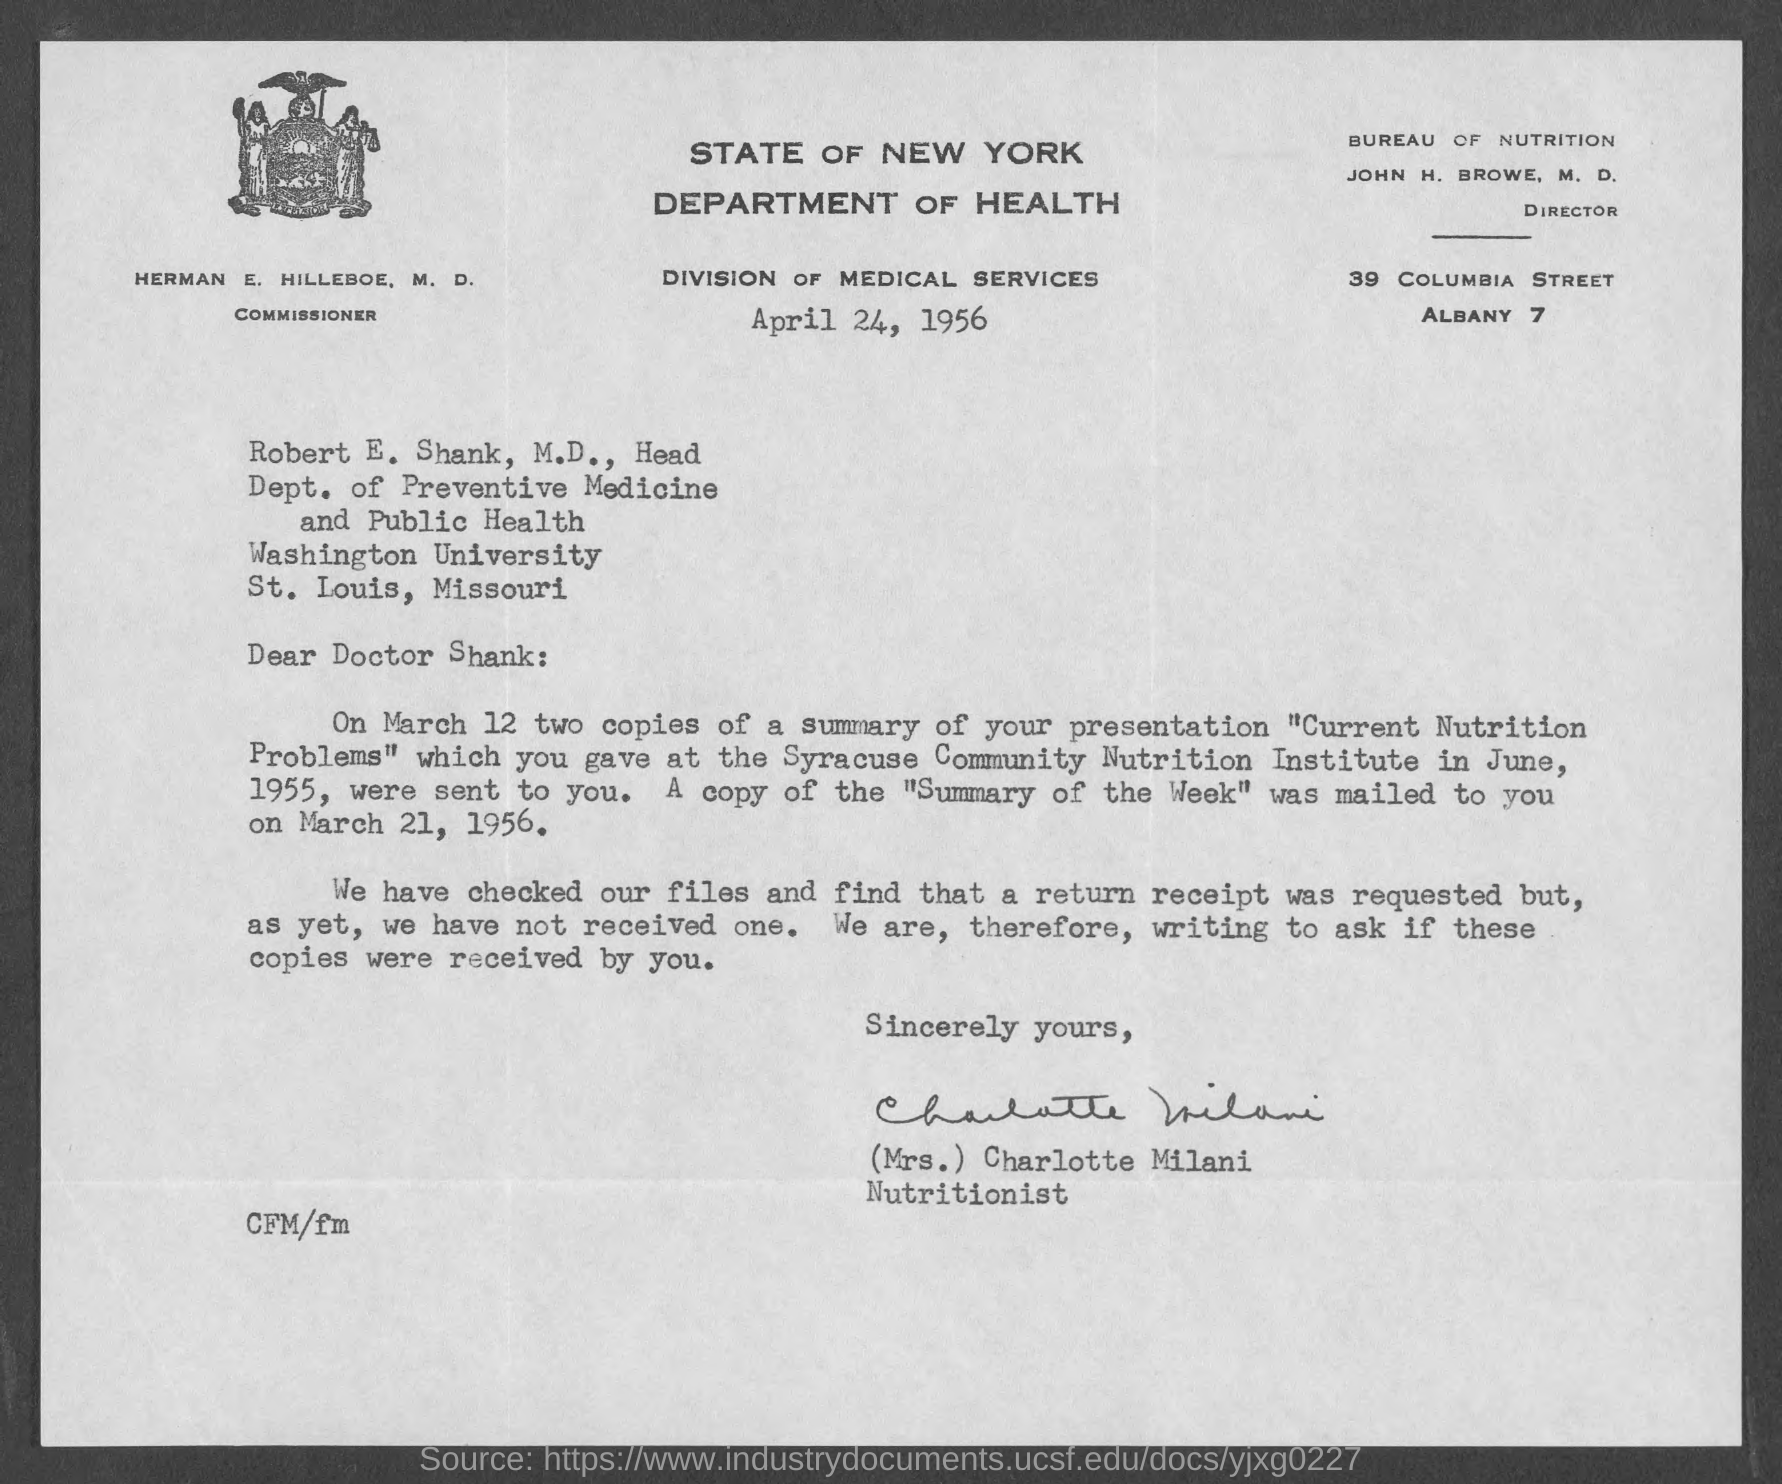Draw attention to some important aspects in this diagram. Charlotte Milani, who is also known as Mrs., is a nutritionist. John H. Browe, M.D., is the Director of the Bureau of Nutrition. On March 21, 1956, a copy of the "Summary of the Week" was mailed to Doctor Shank. The letter has been signed by Mrs. Charlotte Milani. The addressee of this letter is Doctor Shank. 